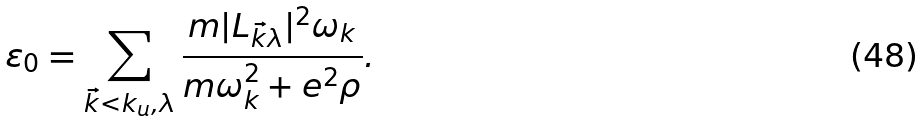Convert formula to latex. <formula><loc_0><loc_0><loc_500><loc_500>\varepsilon _ { 0 } = \sum _ { \vec { k } < k _ { u } , \lambda } \frac { m | L _ { \vec { k } \lambda } | ^ { 2 } \omega _ { k } } { m \omega _ { k } ^ { 2 } + e ^ { 2 } \rho } .</formula> 